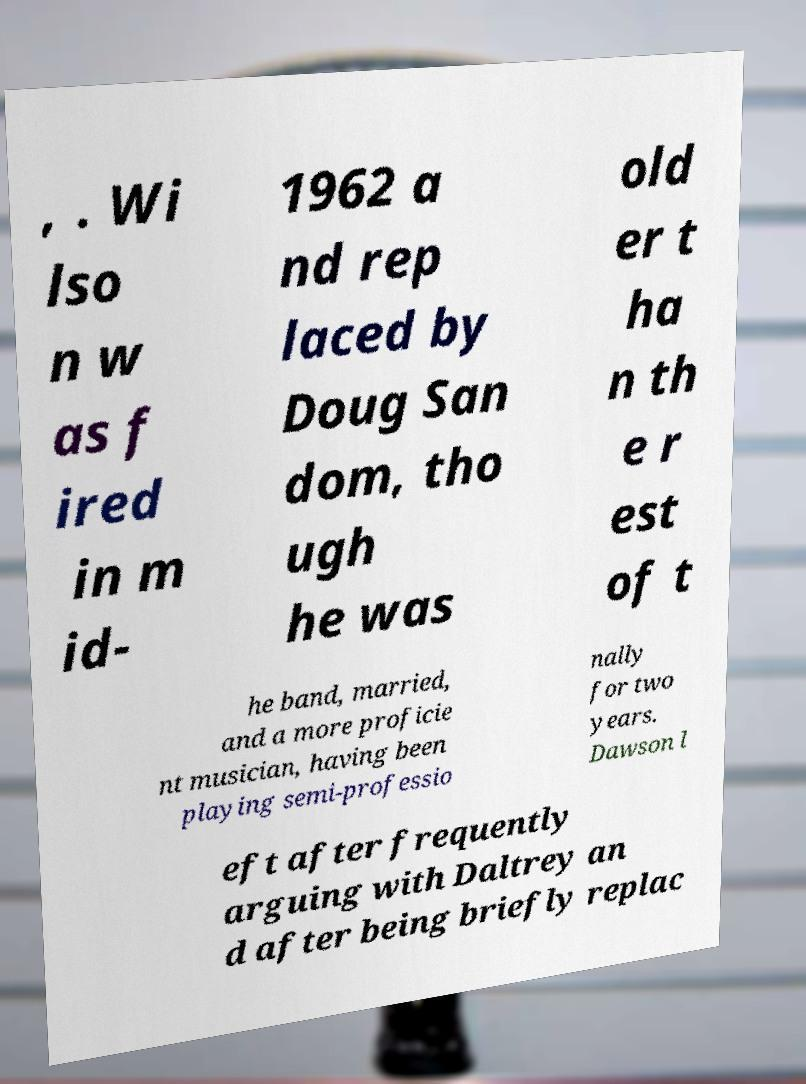Can you read and provide the text displayed in the image?This photo seems to have some interesting text. Can you extract and type it out for me? , . Wi lso n w as f ired in m id- 1962 a nd rep laced by Doug San dom, tho ugh he was old er t ha n th e r est of t he band, married, and a more proficie nt musician, having been playing semi-professio nally for two years. Dawson l eft after frequently arguing with Daltrey an d after being briefly replac 